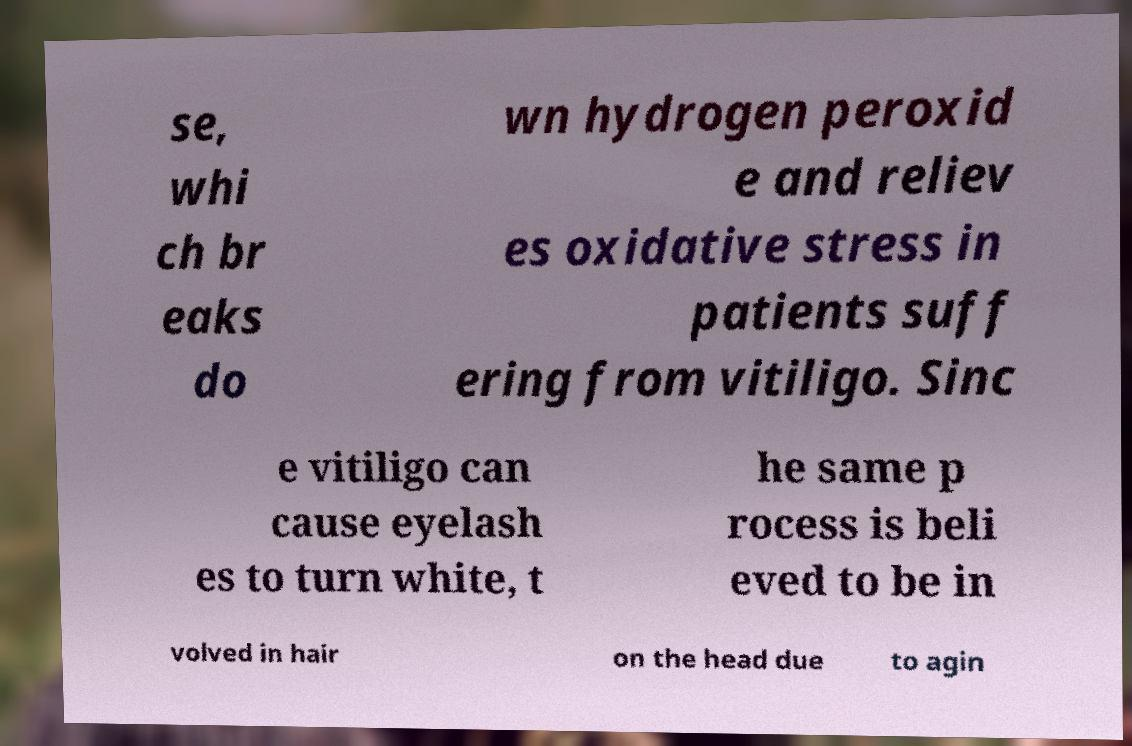For documentation purposes, I need the text within this image transcribed. Could you provide that? se, whi ch br eaks do wn hydrogen peroxid e and reliev es oxidative stress in patients suff ering from vitiligo. Sinc e vitiligo can cause eyelash es to turn white, t he same p rocess is beli eved to be in volved in hair on the head due to agin 